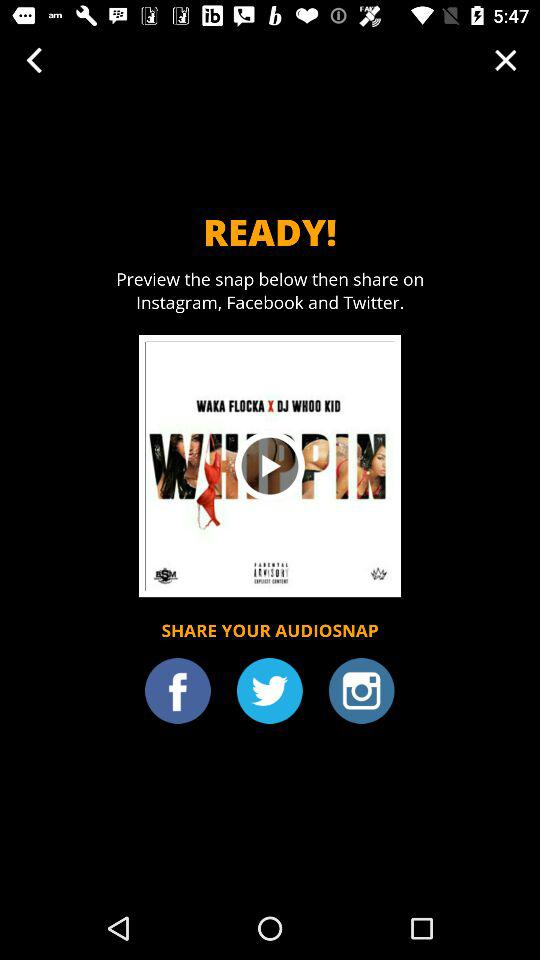Through which app can we share the audiosnap? You can share the audiosnap through "Instagram", "Facebook" and "Twitter". 